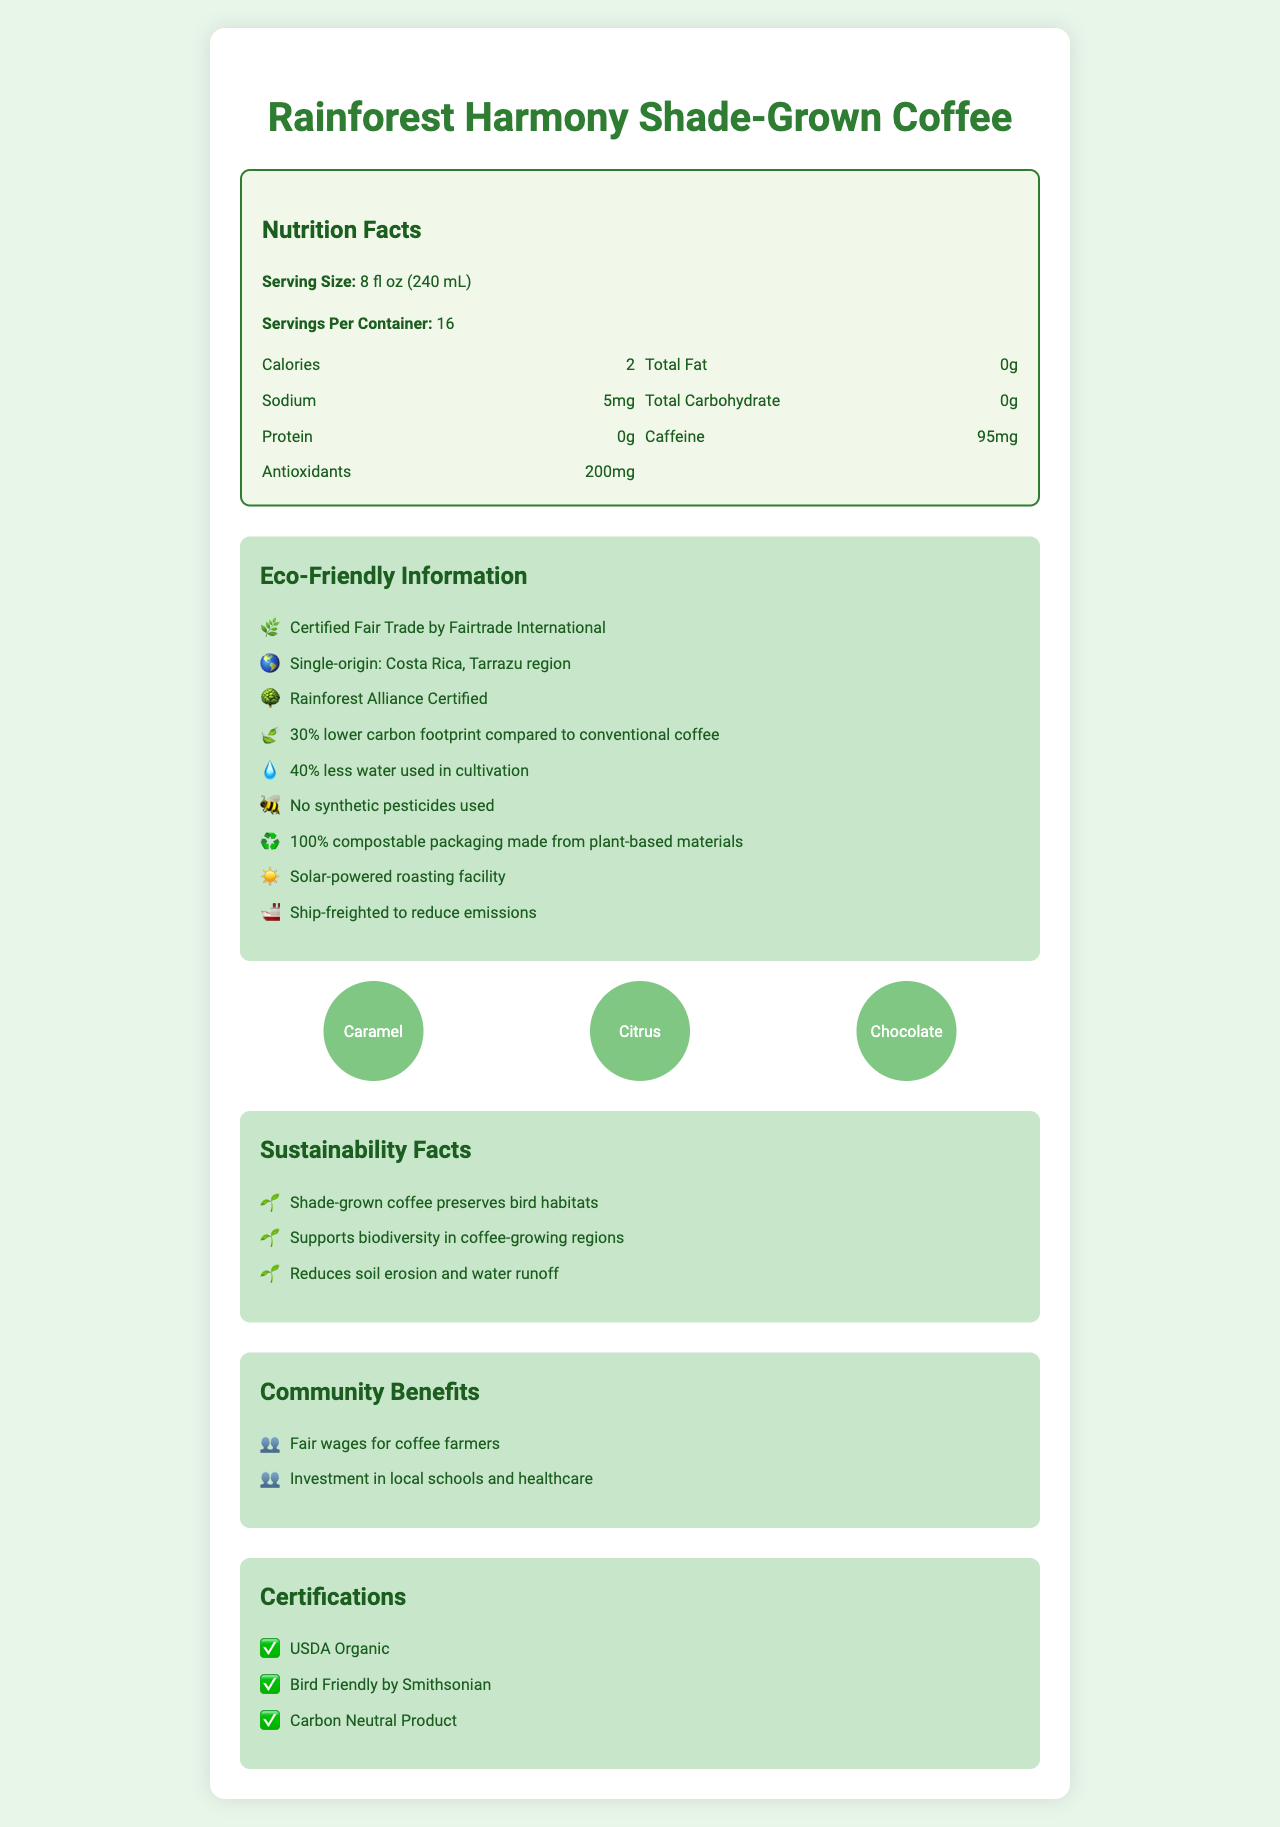what is the serving size of Rainforest Harmony Shade-Grown Coffee? The serving size is explicitly mentioned as "8 fl oz (240 mL)" in the Nutrition Facts section of the document.
Answer: 8 fl oz (240 mL) how many calories are there per serving? The document states that there are 2 calories per serving.
Answer: 2 what is the sodium content per serving? The sodium content per serving is listed as 5mg in the Nutrition Facts.
Answer: 5mg how much caffeine does one serving contain? The caffeine content per serving is stated to be 95mg in the document.
Answer: 95mg List three flavor notes of this coffee. The flavor profile section lists the notes as "Caramel," "Citrus," and "Chocolate."
Answer: Caramel, Citrus, Chocolate what certification supports the fair-trade practice of this coffee? The document mentions plainly that this coffee is "Certified Fair Trade by Fairtrade International."
Answer: Certified Fair Trade by Fairtrade International what region does this coffee originate from? The coffee is specified as single-origin from the "Costa Rica, Tarrazu region."
Answer: Costa Rica, Tarrazu region what percentage of water conservation is achieved in cultivation? The document states that 40% less water is used in cultivation, as noted in the environmental impact section.
Answer: 40% Does this coffee use any synthetic pesticides? The document explicitly states that no synthetic pesticides are used in growing the coffee.
Answer: No what is unique about the packaging of this coffee? The packaging is 100% compostable and made from plant-based materials.
Answer: 100% compostable packaging made from plant-based materials which coffee certifications does Rainforest Harmony Shade-Grown Coffee have? A. USDA Organic B. Bird Friendly by Smithsonian C. Carbon Neutral Product D. All of the Above The document lists all three certifications: USDA Organic, Bird Friendly by Smithsonian, and Carbon Neutral Product.
Answer: D what is the carbon footprint reduction of this coffee compared to conventional coffee? A. 20% B. 25% C. 30% D. 35% The document mentions a 30% lower carbon footprint compared to conventional coffee.
Answer: C which power source is used for the roasting facility? A. Solar B. Wind C. Hydro D. Nuclear The document notes that the coffee is roasted in a "Solar-powered roasting facility."
Answer: A is the coffee fair-trade certified? (Yes/No) The document states it is certified Fair Trade by Fairtrade International.
Answer: Yes Summarize the main benefits of Rainforest Harmony Shade-Grown Coffee. The document provides numerous benefits related to the environment and communities, including fair wages for farmers and investment in local schools, as well as environmental benefits like water conservation, no synthetic pesticides, and biodegradable packaging.
Answer: The coffee offers several environmental and community benefits, including being shade-grown to preserve bird habitats, fair-trade certification to ensure fair wages, organic certification, and it is environmentally friendly with a lower carbon footprint and sustainable packaging. How many grams of protein are in a serving of this coffee? The Nutrition Facts label shows that there are 0g of protein per serving.
Answer: 0g What are the anti-oxidant levels in this coffee per serving? The document mentions that each serving contains 200mg of antioxidants.
Answer: 200mg Describe the specific farming techniques used to grow this coffee. The document does not provide specific farming techniques beyond stating that it is shade-grown and uses no synthetic pesticides.
Answer: Not enough information What community benefits are mentioned for farmers associated with this coffee? The document highlights that farmers receive fair wages and there are investments in local schools and healthcare.
Answer: Fair wages for coffee farmers, investment in local schools and healthcare 